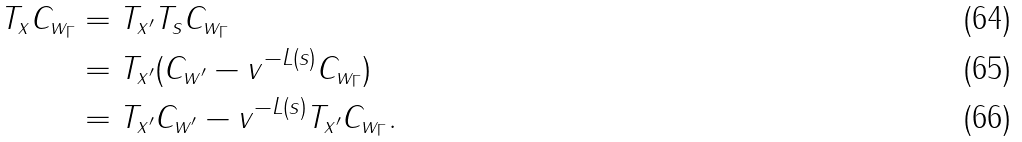Convert formula to latex. <formula><loc_0><loc_0><loc_500><loc_500>T _ { x } C _ { w _ { \Gamma } } & = T _ { x ^ { \prime } } T _ { s } C _ { w _ { \Gamma } } \\ & = T _ { x ^ { \prime } } ( C _ { w ^ { \prime } } - v ^ { - L ( s ) } C _ { w _ { \Gamma } } ) \\ & = T _ { x ^ { \prime } } C _ { w ^ { \prime } } - v ^ { - L ( s ) } T _ { x ^ { \prime } } C _ { w _ { \Gamma } } .</formula> 